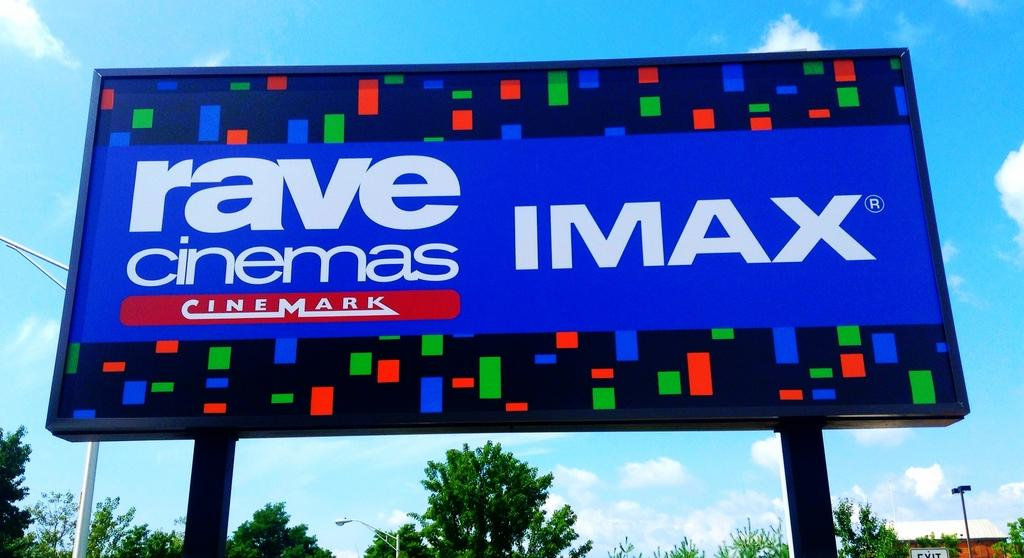<image>
Describe the image concisely. A colorful billboard for Rave Cinemas Imax Theatre sits above the trees 